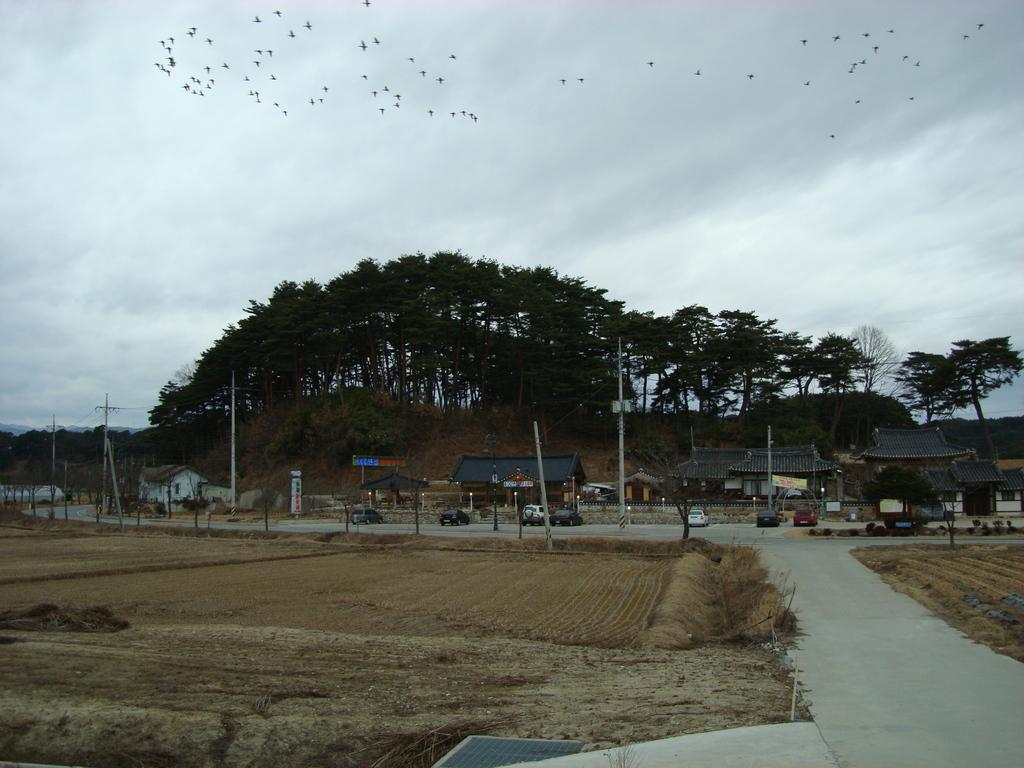What type of surface can be seen in the image? There is ground visible in the image. What objects are present that resemble long, thin structures? There are rods and poles in the image. What other objects can be seen in the image? There are boards, vehicles, houses, and trees in the image. What is happening in the background of the image? In the background, birds are flying in the sky. What sound can be heard coming from the son in the image? There is no son present in the image, and therefore no sound can be heard coming from him. 